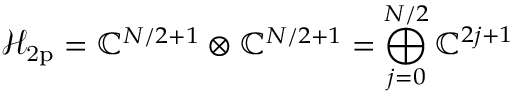<formula> <loc_0><loc_0><loc_500><loc_500>\mathcal { H } _ { 2 p } = { \mathbb { C } ^ { N / 2 + 1 } \otimes \mathbb { C } ^ { N / 2 + 1 } = \bigoplus _ { j = 0 } ^ { N / 2 } \mathbb { C } ^ { 2 j + 1 } }</formula> 